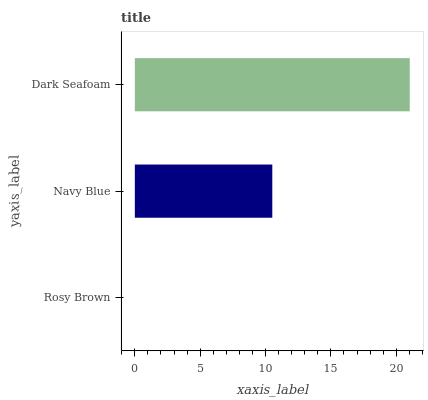Is Rosy Brown the minimum?
Answer yes or no. Yes. Is Dark Seafoam the maximum?
Answer yes or no. Yes. Is Navy Blue the minimum?
Answer yes or no. No. Is Navy Blue the maximum?
Answer yes or no. No. Is Navy Blue greater than Rosy Brown?
Answer yes or no. Yes. Is Rosy Brown less than Navy Blue?
Answer yes or no. Yes. Is Rosy Brown greater than Navy Blue?
Answer yes or no. No. Is Navy Blue less than Rosy Brown?
Answer yes or no. No. Is Navy Blue the high median?
Answer yes or no. Yes. Is Navy Blue the low median?
Answer yes or no. Yes. Is Dark Seafoam the high median?
Answer yes or no. No. Is Rosy Brown the low median?
Answer yes or no. No. 